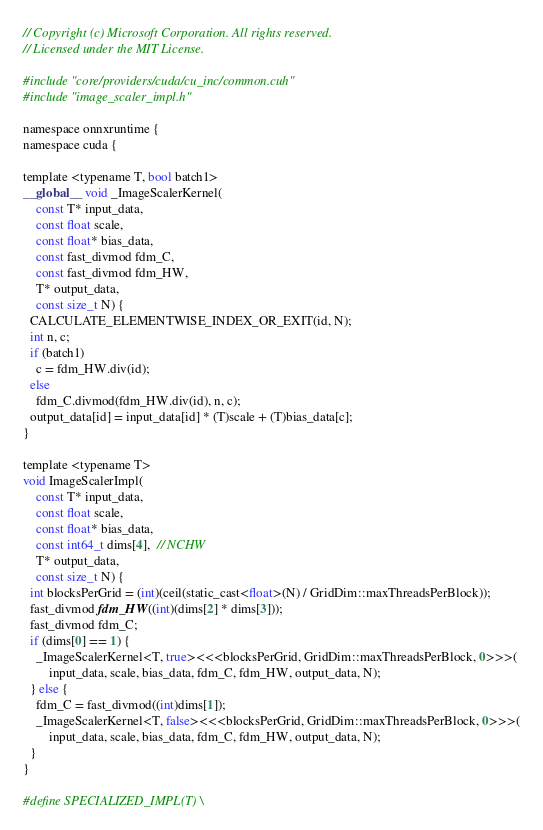<code> <loc_0><loc_0><loc_500><loc_500><_Cuda_>// Copyright (c) Microsoft Corporation. All rights reserved.
// Licensed under the MIT License.

#include "core/providers/cuda/cu_inc/common.cuh"
#include "image_scaler_impl.h"

namespace onnxruntime {
namespace cuda {

template <typename T, bool batch1>
__global__ void _ImageScalerKernel(
    const T* input_data,
    const float scale,
    const float* bias_data,
    const fast_divmod fdm_C,
    const fast_divmod fdm_HW,
    T* output_data,
    const size_t N) {
  CALCULATE_ELEMENTWISE_INDEX_OR_EXIT(id, N);
  int n, c;
  if (batch1)
    c = fdm_HW.div(id);
  else
    fdm_C.divmod(fdm_HW.div(id), n, c);
  output_data[id] = input_data[id] * (T)scale + (T)bias_data[c];
}

template <typename T>
void ImageScalerImpl(
    const T* input_data,
    const float scale,
    const float* bias_data,
    const int64_t dims[4],  // NCHW
    T* output_data,
    const size_t N) {
  int blocksPerGrid = (int)(ceil(static_cast<float>(N) / GridDim::maxThreadsPerBlock));
  fast_divmod fdm_HW((int)(dims[2] * dims[3]));
  fast_divmod fdm_C;
  if (dims[0] == 1) {
    _ImageScalerKernel<T, true><<<blocksPerGrid, GridDim::maxThreadsPerBlock, 0>>>(
        input_data, scale, bias_data, fdm_C, fdm_HW, output_data, N);
  } else {
    fdm_C = fast_divmod((int)dims[1]);
    _ImageScalerKernel<T, false><<<blocksPerGrid, GridDim::maxThreadsPerBlock, 0>>>(
        input_data, scale, bias_data, fdm_C, fdm_HW, output_data, N);
  }
}

#define SPECIALIZED_IMPL(T) \</code> 